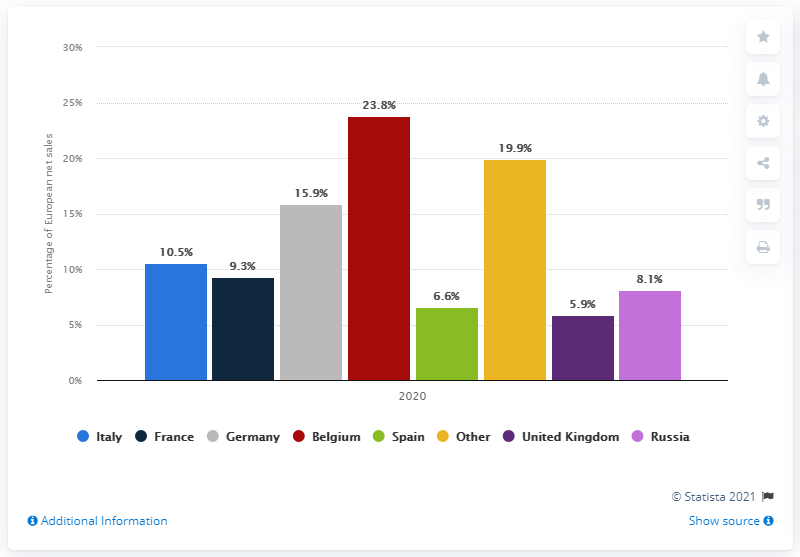Indicate a few pertinent items in this graphic. The percentage of Italy and Russia's European net sales differ from each other. According to data from Samsonite's 2020 annual report, 23.8% of the company's net sales in Europe were generated by the country of Belgium. Belgium has the highest percentage of European net sales among all countries. In 2020, Samsonite's net sales in Europe occurred. 